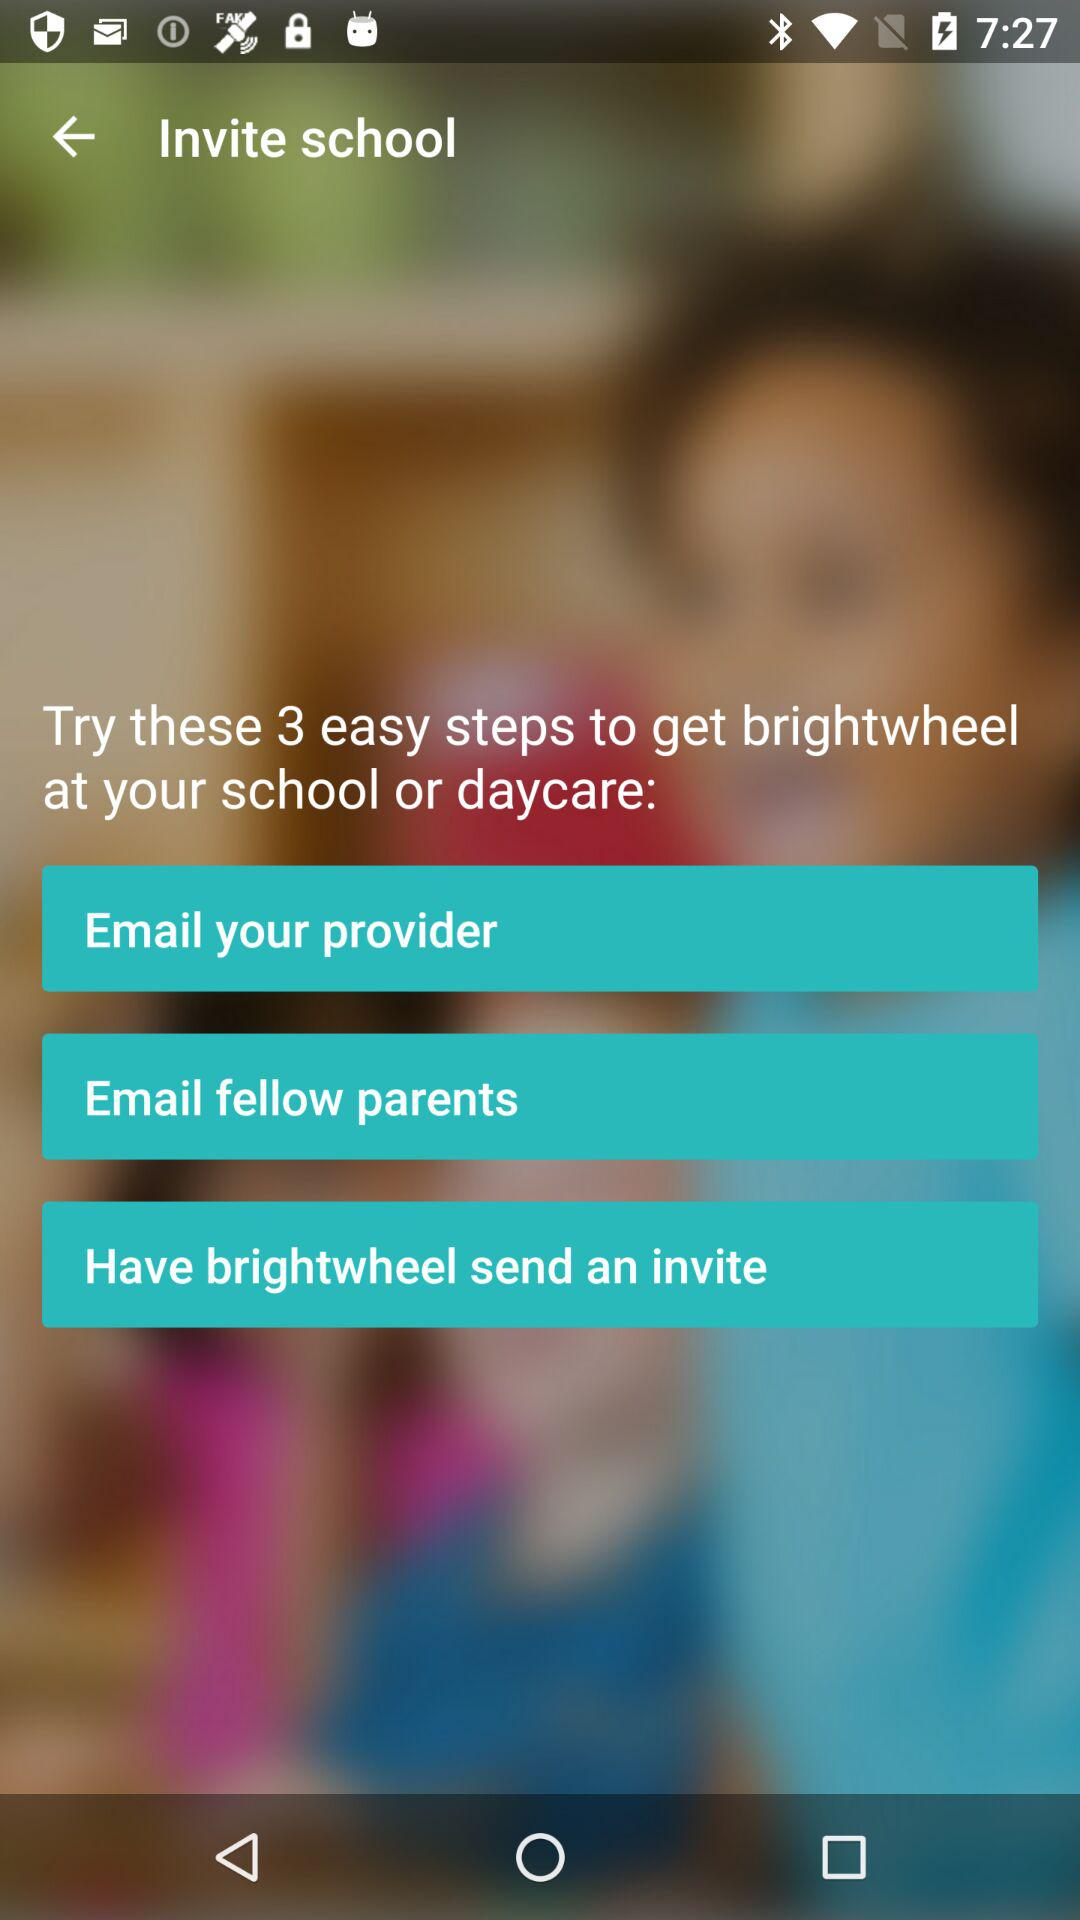How many steps in total are there? There are 3 steps in total. 